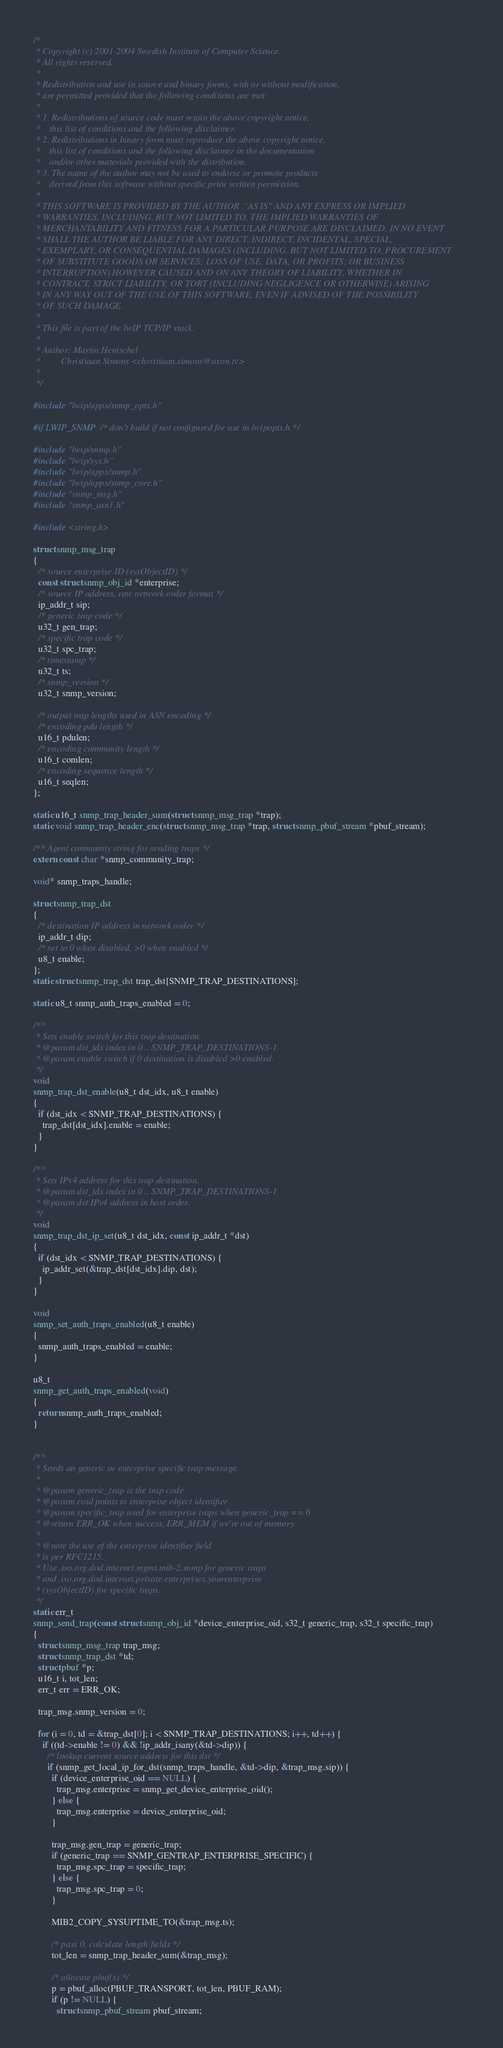<code> <loc_0><loc_0><loc_500><loc_500><_C_>/*
 * Copyright (c) 2001-2004 Swedish Institute of Computer Science.
 * All rights reserved.
 *
 * Redistribution and use in source and binary forms, with or without modification,
 * are permitted provided that the following conditions are met:
 *
 * 1. Redistributions of source code must retain the above copyright notice,
 *    this list of conditions and the following disclaimer.
 * 2. Redistributions in binary form must reproduce the above copyright notice,
 *    this list of conditions and the following disclaimer in the documentation
 *    and/or other materials provided with the distribution.
 * 3. The name of the author may not be used to endorse or promote products
 *    derived from this software without specific prior written permission.
 *
 * THIS SOFTWARE IS PROVIDED BY THE AUTHOR ``AS IS'' AND ANY EXPRESS OR IMPLIED
 * WARRANTIES, INCLUDING, BUT NOT LIMITED TO, THE IMPLIED WARRANTIES OF
 * MERCHANTABILITY AND FITNESS FOR A PARTICULAR PURPOSE ARE DISCLAIMED. IN NO EVENT
 * SHALL THE AUTHOR BE LIABLE FOR ANY DIRECT, INDIRECT, INCIDENTAL, SPECIAL,
 * EXEMPLARY, OR CONSEQUENTIAL DAMAGES (INCLUDING, BUT NOT LIMITED TO, PROCUREMENT
 * OF SUBSTITUTE GOODS OR SERVICES; LOSS OF USE, DATA, OR PROFITS; OR BUSINESS
 * INTERRUPTION) HOWEVER CAUSED AND ON ANY THEORY OF LIABILITY, WHETHER IN
 * CONTRACT, STRICT LIABILITY, OR TORT (INCLUDING NEGLIGENCE OR OTHERWISE) ARISING
 * IN ANY WAY OUT OF THE USE OF THIS SOFTWARE, EVEN IF ADVISED OF THE POSSIBILITY
 * OF SUCH DAMAGE.
 *
 * This file is part of the lwIP TCP/IP stack.
 *
 * Author: Martin Hentschel
 *         Christiaan Simons <christiaan.simons@axon.tv>
 *
 */

#include "lwip/apps/snmp_opts.h"

#if LWIP_SNMP /* don't build if not configured for use in lwipopts.h */

#include "lwip/snmp.h"
#include "lwip/sys.h"
#include "lwip/apps/snmp.h"
#include "lwip/apps/snmp_core.h"
#include "snmp_msg.h"
#include "snmp_asn1.h"

#include <string.h>

struct snmp_msg_trap
{
  /* source enterprise ID (sysObjectID) */
  const struct snmp_obj_id *enterprise;
  /* source IP address, raw network order format */
  ip_addr_t sip;
  /* generic trap code */
  u32_t gen_trap;
  /* specific trap code */
  u32_t spc_trap;
  /* timestamp */
  u32_t ts;
  /* snmp_version */
  u32_t snmp_version;

  /* output trap lengths used in ASN encoding */
  /* encoding pdu length */
  u16_t pdulen;
  /* encoding community length */
  u16_t comlen;
  /* encoding sequence length */
  u16_t seqlen;
};

static u16_t snmp_trap_header_sum(struct snmp_msg_trap *trap);
static void snmp_trap_header_enc(struct snmp_msg_trap *trap, struct snmp_pbuf_stream *pbuf_stream);

/** Agent community string for sending traps */
extern const char *snmp_community_trap;

void* snmp_traps_handle;

struct snmp_trap_dst
{
  /* destination IP address in network order */
  ip_addr_t dip;
  /* set to 0 when disabled, >0 when enabled */
  u8_t enable;
};
static struct snmp_trap_dst trap_dst[SNMP_TRAP_DESTINATIONS];

static u8_t snmp_auth_traps_enabled = 0;

/**
 * Sets enable switch for this trap destination.
 * @param dst_idx index in 0 .. SNMP_TRAP_DESTINATIONS-1
 * @param enable switch if 0 destination is disabled >0 enabled.
 */
void
snmp_trap_dst_enable(u8_t dst_idx, u8_t enable)
{
  if (dst_idx < SNMP_TRAP_DESTINATIONS) {
    trap_dst[dst_idx].enable = enable;
  }
}

/**
 * Sets IPv4 address for this trap destination.
 * @param dst_idx index in 0 .. SNMP_TRAP_DESTINATIONS-1
 * @param dst IPv4 address in host order.
 */
void
snmp_trap_dst_ip_set(u8_t dst_idx, const ip_addr_t *dst)
{
  if (dst_idx < SNMP_TRAP_DESTINATIONS) {
    ip_addr_set(&trap_dst[dst_idx].dip, dst);
  }
}

void
snmp_set_auth_traps_enabled(u8_t enable)
{
  snmp_auth_traps_enabled = enable;
}

u8_t
snmp_get_auth_traps_enabled(void)
{
  return snmp_auth_traps_enabled;
}


/**
 * Sends an generic or enterprise specific trap message.
 *
 * @param generic_trap is the trap code
 * @param eoid points to enterprise object identifier
 * @param specific_trap used for enterprise traps when generic_trap == 6
 * @return ERR_OK when success, ERR_MEM if we're out of memory
 *
 * @note the use of the enterprise identifier field
 * is per RFC1215.
 * Use .iso.org.dod.internet.mgmt.mib-2.snmp for generic traps
 * and .iso.org.dod.internet.private.enterprises.yourenterprise
 * (sysObjectID) for specific traps.
 */
static err_t
snmp_send_trap(const struct snmp_obj_id *device_enterprise_oid, s32_t generic_trap, s32_t specific_trap)
{
  struct snmp_msg_trap trap_msg;
  struct snmp_trap_dst *td;
  struct pbuf *p;
  u16_t i, tot_len;
  err_t err = ERR_OK;

  trap_msg.snmp_version = 0;

  for (i = 0, td = &trap_dst[0]; i < SNMP_TRAP_DESTINATIONS; i++, td++) {
    if ((td->enable != 0) && !ip_addr_isany(&td->dip)) {
      /* lookup current source address for this dst */
      if (snmp_get_local_ip_for_dst(snmp_traps_handle, &td->dip, &trap_msg.sip)) {
        if (device_enterprise_oid == NULL) {
          trap_msg.enterprise = snmp_get_device_enterprise_oid();
        } else {
          trap_msg.enterprise = device_enterprise_oid;
        }

        trap_msg.gen_trap = generic_trap;
        if (generic_trap == SNMP_GENTRAP_ENTERPRISE_SPECIFIC) {
          trap_msg.spc_trap = specific_trap;
        } else {
          trap_msg.spc_trap = 0;
        }

        MIB2_COPY_SYSUPTIME_TO(&trap_msg.ts);

        /* pass 0, calculate length fields */
        tot_len = snmp_trap_header_sum(&trap_msg);

        /* allocate pbuf(s) */
        p = pbuf_alloc(PBUF_TRANSPORT, tot_len, PBUF_RAM);
        if (p != NULL) {
          struct snmp_pbuf_stream pbuf_stream;</code> 